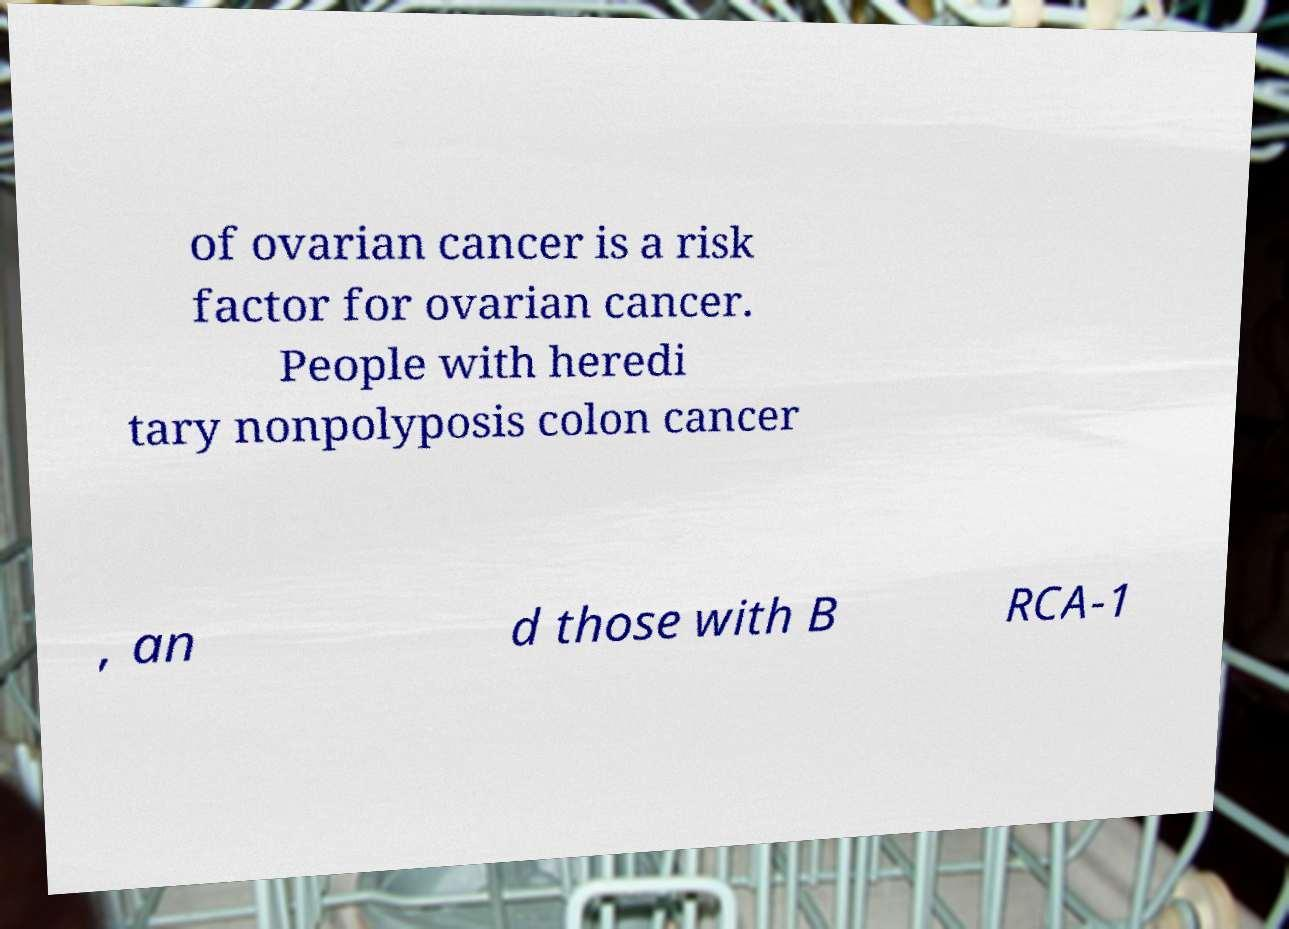Could you assist in decoding the text presented in this image and type it out clearly? of ovarian cancer is a risk factor for ovarian cancer. People with heredi tary nonpolyposis colon cancer , an d those with B RCA-1 